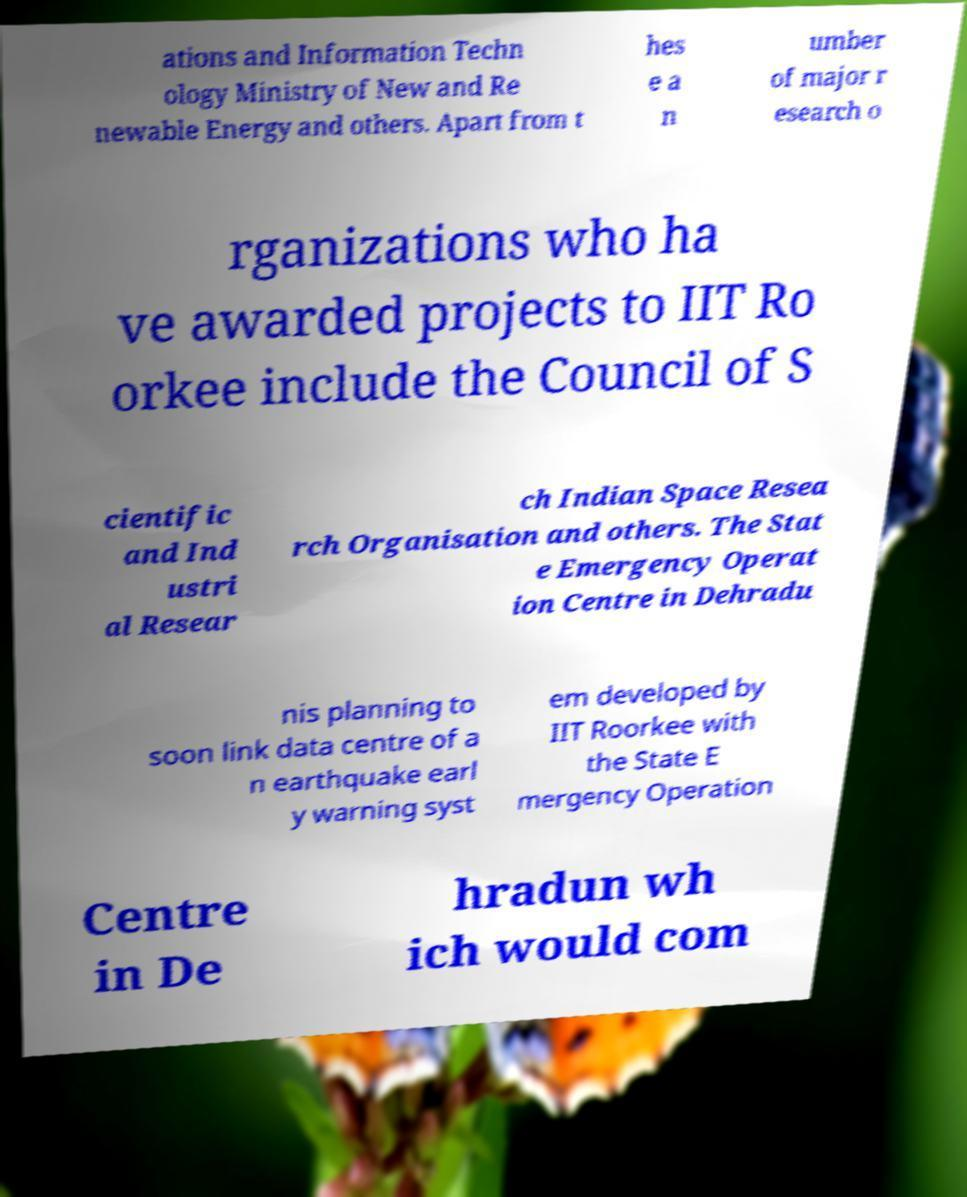I need the written content from this picture converted into text. Can you do that? ations and Information Techn ology Ministry of New and Re newable Energy and others. Apart from t hes e a n umber of major r esearch o rganizations who ha ve awarded projects to IIT Ro orkee include the Council of S cientific and Ind ustri al Resear ch Indian Space Resea rch Organisation and others. The Stat e Emergency Operat ion Centre in Dehradu nis planning to soon link data centre of a n earthquake earl y warning syst em developed by IIT Roorkee with the State E mergency Operation Centre in De hradun wh ich would com 